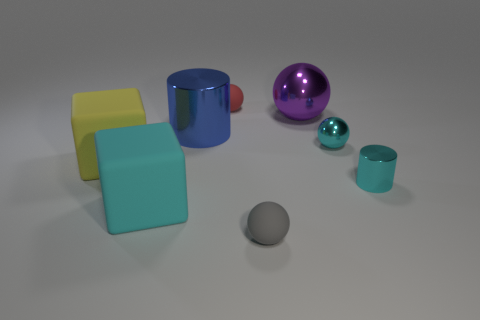Subtract all purple shiny spheres. How many spheres are left? 3 Subtract all purple balls. How many balls are left? 3 Subtract all blue balls. Subtract all gray cylinders. How many balls are left? 4 Add 2 large cyan matte cubes. How many objects exist? 10 Subtract all cylinders. How many objects are left? 6 Add 5 large metal cylinders. How many large metal cylinders are left? 6 Add 3 big red rubber balls. How many big red rubber balls exist? 3 Subtract 1 yellow cubes. How many objects are left? 7 Subtract all purple balls. Subtract all yellow things. How many objects are left? 6 